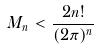Convert formula to latex. <formula><loc_0><loc_0><loc_500><loc_500>M _ { n } < \frac { 2 n ! } { ( 2 \pi ) ^ { n } }</formula> 